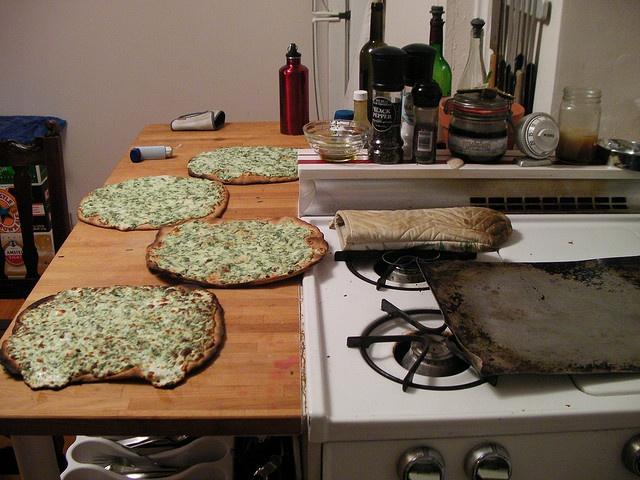Describe the objects in this image and their specific colors. I can see oven in gray, black, and darkgray tones, pizza in gray, tan, and maroon tones, pizza in gray, tan, and black tones, pizza in gray, tan, and beige tones, and pizza in gray, tan, and brown tones in this image. 